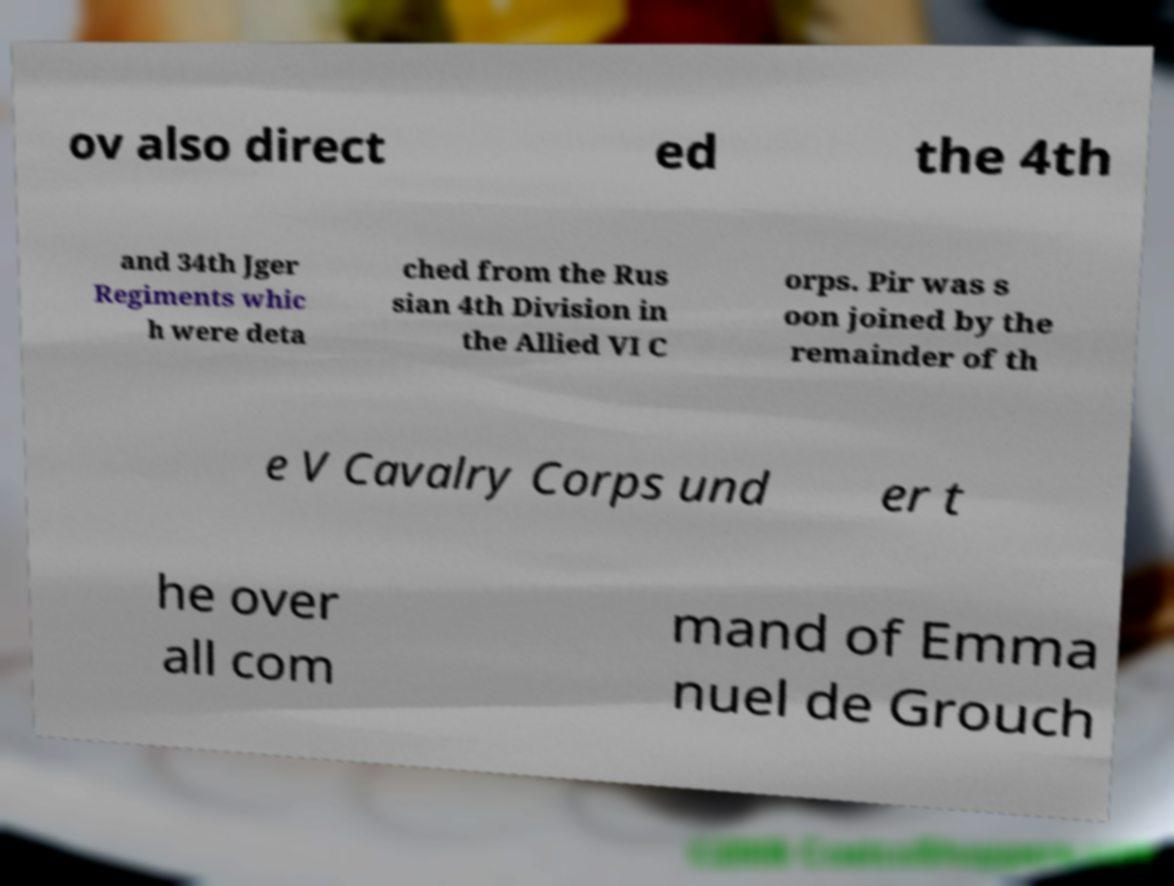Please read and relay the text visible in this image. What does it say? ov also direct ed the 4th and 34th Jger Regiments whic h were deta ched from the Rus sian 4th Division in the Allied VI C orps. Pir was s oon joined by the remainder of th e V Cavalry Corps und er t he over all com mand of Emma nuel de Grouch 